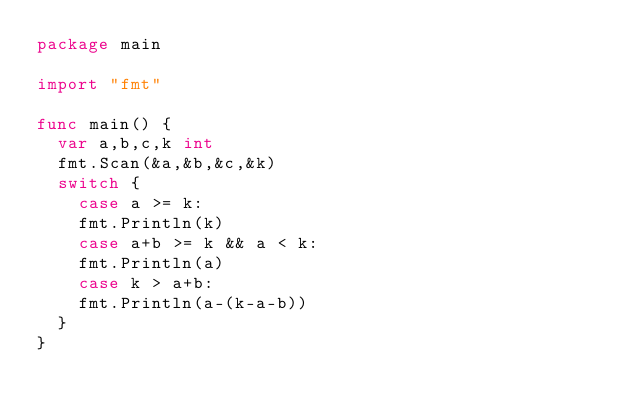Convert code to text. <code><loc_0><loc_0><loc_500><loc_500><_Go_>package main
 
import "fmt"
 
func main() {
  var a,b,c,k int
  fmt.Scan(&a,&b,&c,&k)
  switch {
    case a >= k:
    fmt.Println(k)
    case a+b >= k && a < k:
    fmt.Println(a)
    case k > a+b:
    fmt.Println(a-(k-a-b))
  }
}</code> 